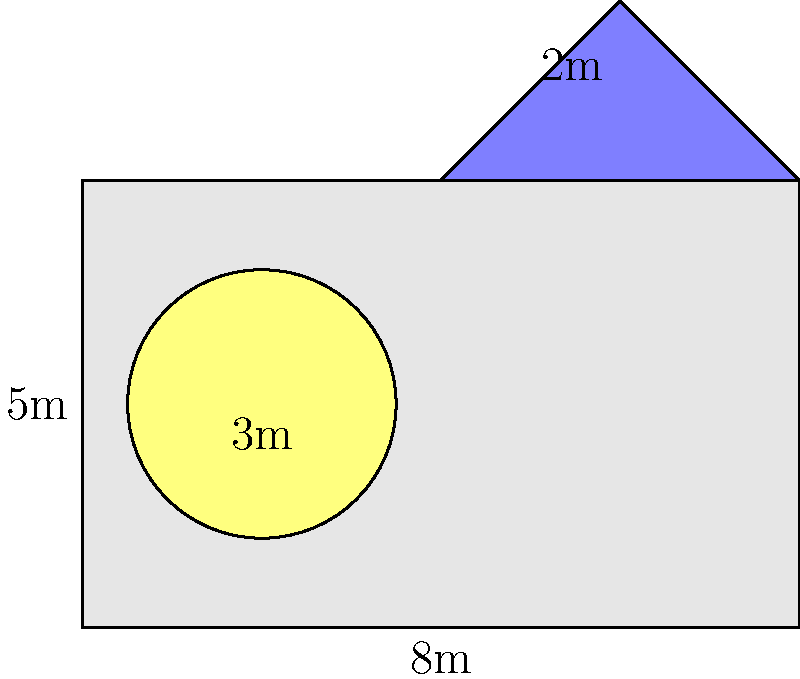A resistance artist in Syria has created a mural on a rectangular wall. The mural consists of a rectangular base, a triangular top representing a mountain, and a circular design symbolizing unity. The wall is 8 meters wide and 5 meters high. The triangular top extends 2 meters above the rectangle. A circular design with a diameter of 3 meters is placed within the rectangle. Calculate the total area of the wall covered by the mural, excluding the area of the circular design. To solve this problem, we need to calculate the areas of the rectangular base and the triangular top, then subtract the area of the circular design:

1. Area of the rectangular base:
   $A_{rectangle} = width \times height = 8m \times 5m = 40m^2$

2. Area of the triangular top:
   $A_{triangle} = \frac{1}{2} \times base \times height = \frac{1}{2} \times 8m \times 2m = 8m^2$

3. Area of the circular design:
   $A_{circle} = \pi r^2 = \pi \times (\frac{3m}{2})^2 = \frac{9\pi}{4}m^2$

4. Total area covered by the mural:
   $A_{total} = A_{rectangle} + A_{triangle} - A_{circle}$
   $A_{total} = 40m^2 + 8m^2 - \frac{9\pi}{4}m^2$
   $A_{total} = 48 - \frac{9\pi}{4}m^2$

Therefore, the total area of the wall covered by the mural, excluding the circular design, is $48 - \frac{9\pi}{4}m^2$.
Answer: $48 - \frac{9\pi}{4}m^2$ 